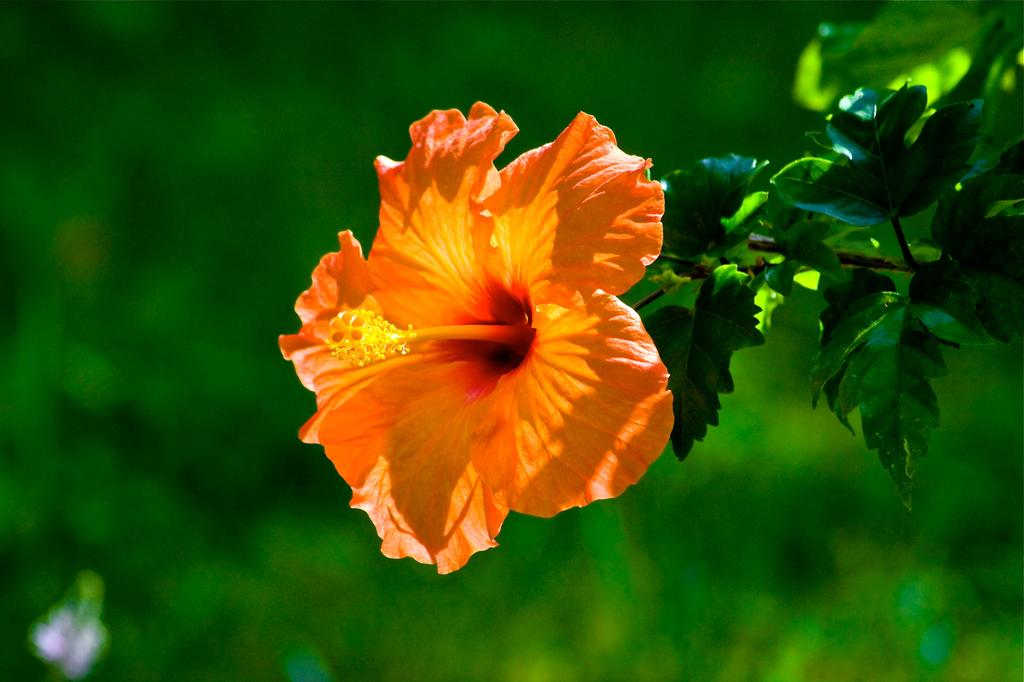What is the main subject of the image? The main subject of the image is a flower. Can you describe the flower's structure? The flower has a stem and leaves. What color is the background of the image? The background of the image is green. What type of work does the secretary do in the image? There is no secretary present in the image; it features a flower with a stem and leaves against a green background. 